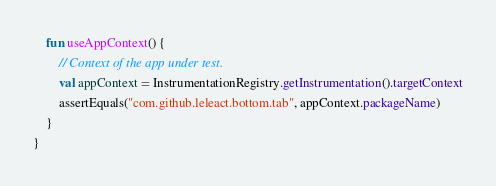<code> <loc_0><loc_0><loc_500><loc_500><_Kotlin_>    fun useAppContext() {
        // Context of the app under test.
        val appContext = InstrumentationRegistry.getInstrumentation().targetContext
        assertEquals("com.github.leleact.bottom.tab", appContext.packageName)
    }
}
</code> 